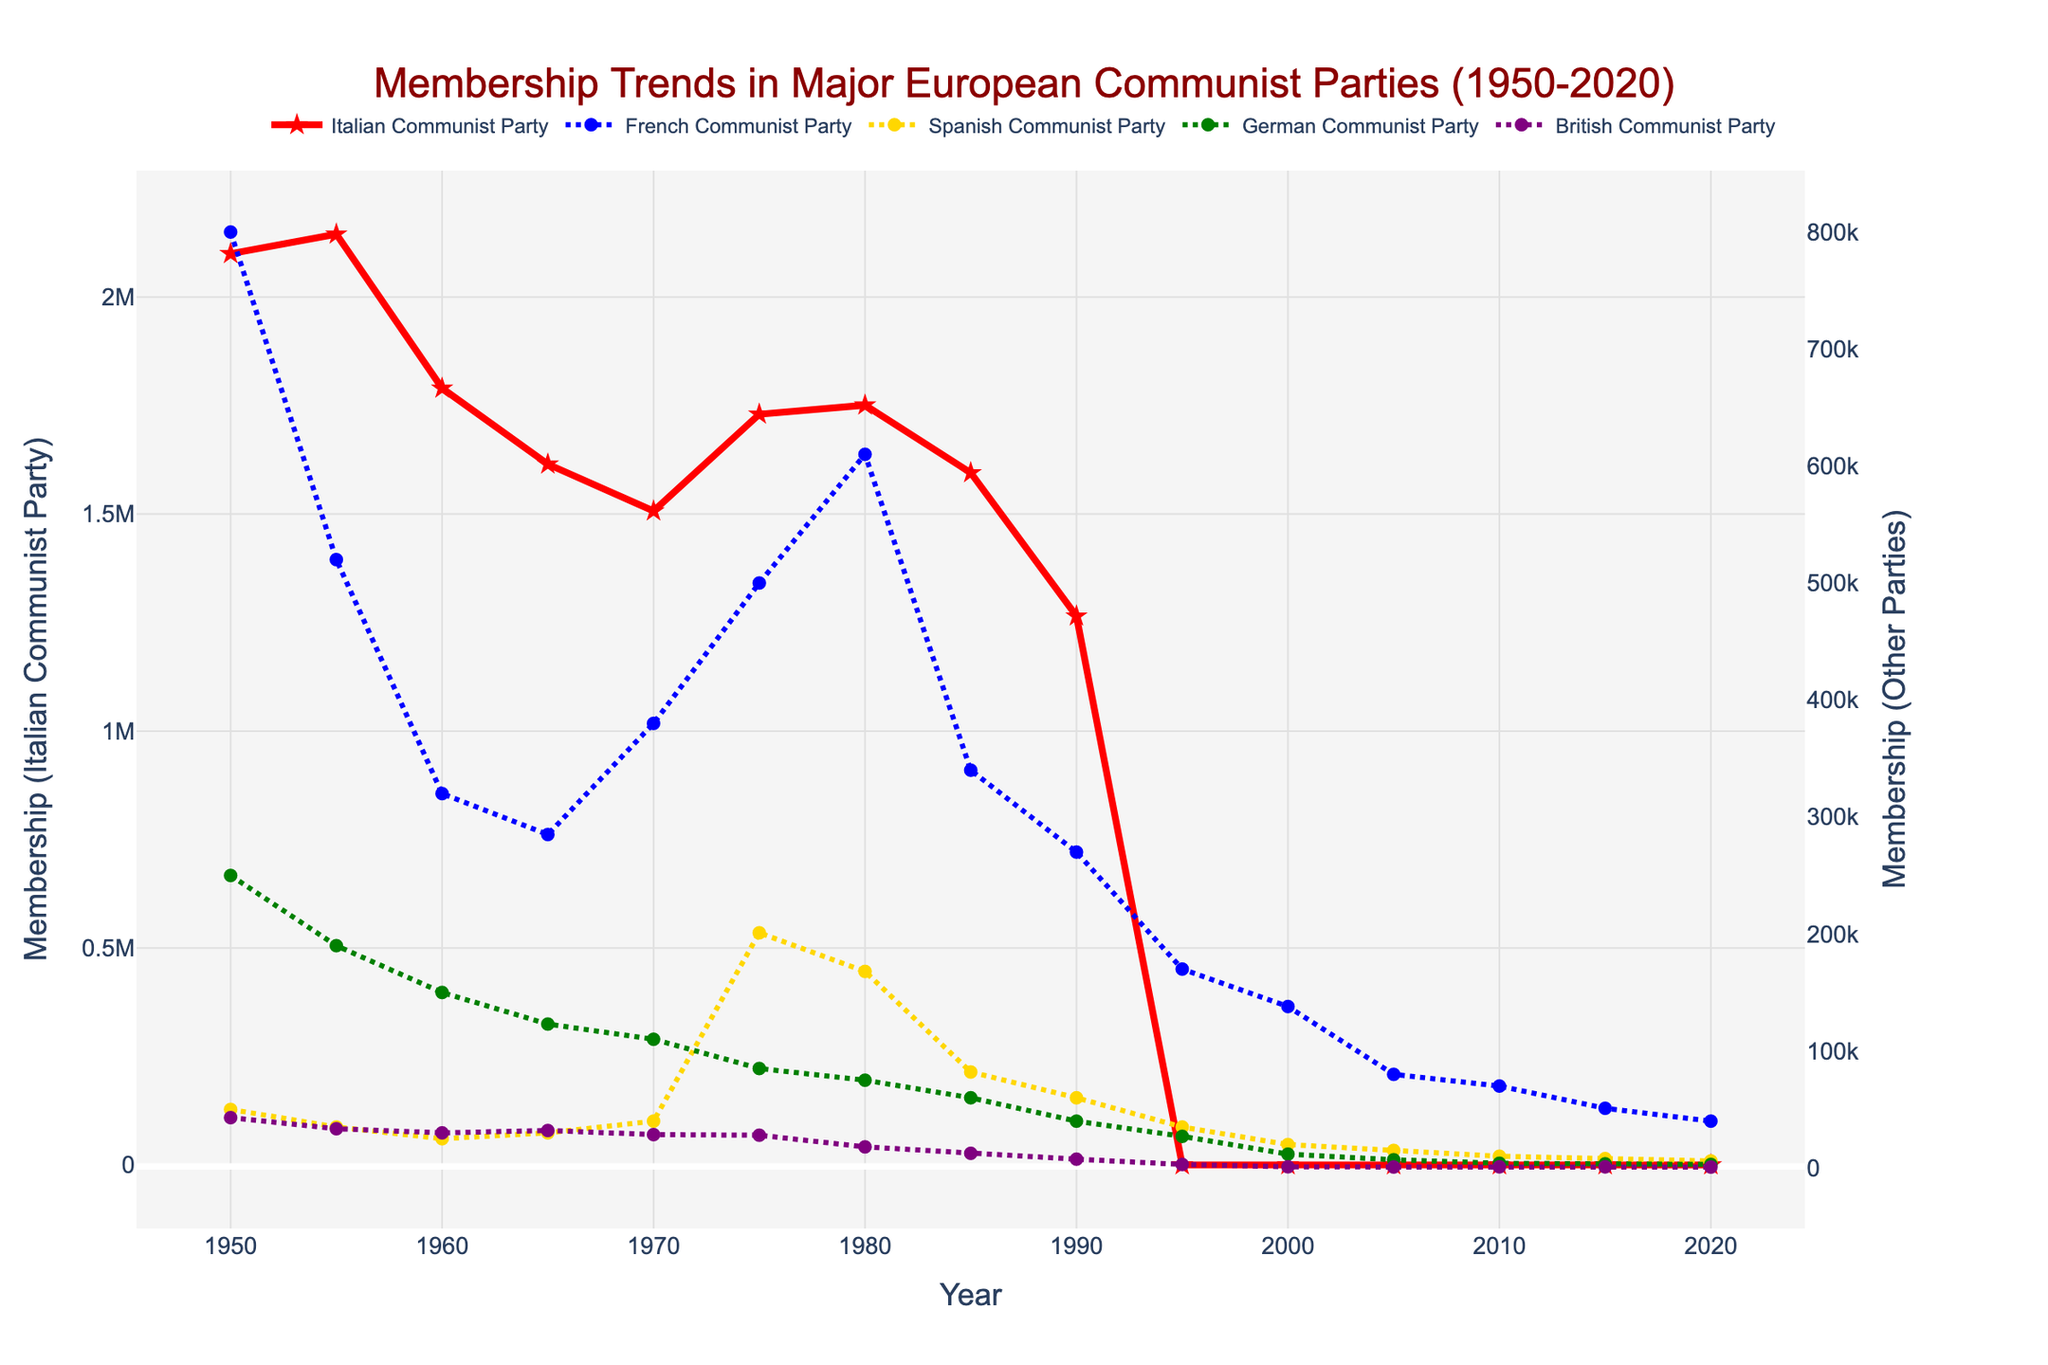Which party had the highest membership in 1950? From the figure, look at the membership values for each party in 1950. The Italian Communist Party had the highest membership with 2,100,000 members.
Answer: Italian Communist Party Which party experienced the greatest decline in membership from 1950 to 2000? For each party, subtract the membership in 2000 from the membership in 1950. The Italian Communist Party had the highest decline, reducing from 2,100,000 to 0.
Answer: Italian Communist Party Which two parties had very similar membership numbers in 1985? Compare the membership values visually in 1985. Both the German Communist Party and the Spanish Communist Party had similar membership numbers, approximately 60,000–82,000 members.
Answer: German Communist Party and Spanish Communist Party How did the membership of the French Communist Party change from 1955 to 1975? Check the membership values for the French Communist Party between 1955 and 1975. The values changed from 520,000 in 1955 to 500,000 in 1975, indicating a small decrease.
Answer: Small decrease Which party had almost constant membership, showing minimal fluctuations, and which in general trended downwards? Visually inspect each party's membership trends. The British Communist Party showed minimal fluctuations and general downward trends throughout the period.
Answer: British Communist Party What is the combined membership of the German and Spanish Communist Parties in 1975? Add the membership of the German and Spanish Communist Parties in 1975. They had 85,000 and 201,000 members respectively, leading to a combined total of 286,000 members.
Answer: 286,000 In which year did the Italian Communist Party's membership drop below 2 million for the first time, and what was the value? Identify the year when the membership of the Italian Communist Party first drops below 2 million. It was in 1960 with a value of 1,790,000 members.
Answer: 1960, 1,790,000 Compare the membership trend of the French and Italian Communist Parties from 1950 to 2020. Look at the overall trends for both parties. The Italian Communist Party shows a steady decline ending in 1991, and the French Communist Party exhibits fluctuations with an overall downward trend.
Answer: Steady decline (Italian), Fluctuations but decline overall (French) Which party saw a substantial increase in membership in the period 1970 to 1975? Identify the party with the most significant increase in membership between 1970 and 1975. The Spanish Communist Party saw an increase from 40,000 to 201,000 members.
Answer: Spanish Communist Party What was the membership trend of the British Communist Party from 1980 to 2020? Examine the line corresponding to the British Communist Party from 1980 to 2020. There is a steady decline from 18,000 in 1980 to 750 in 2020.
Answer: Steady decline 